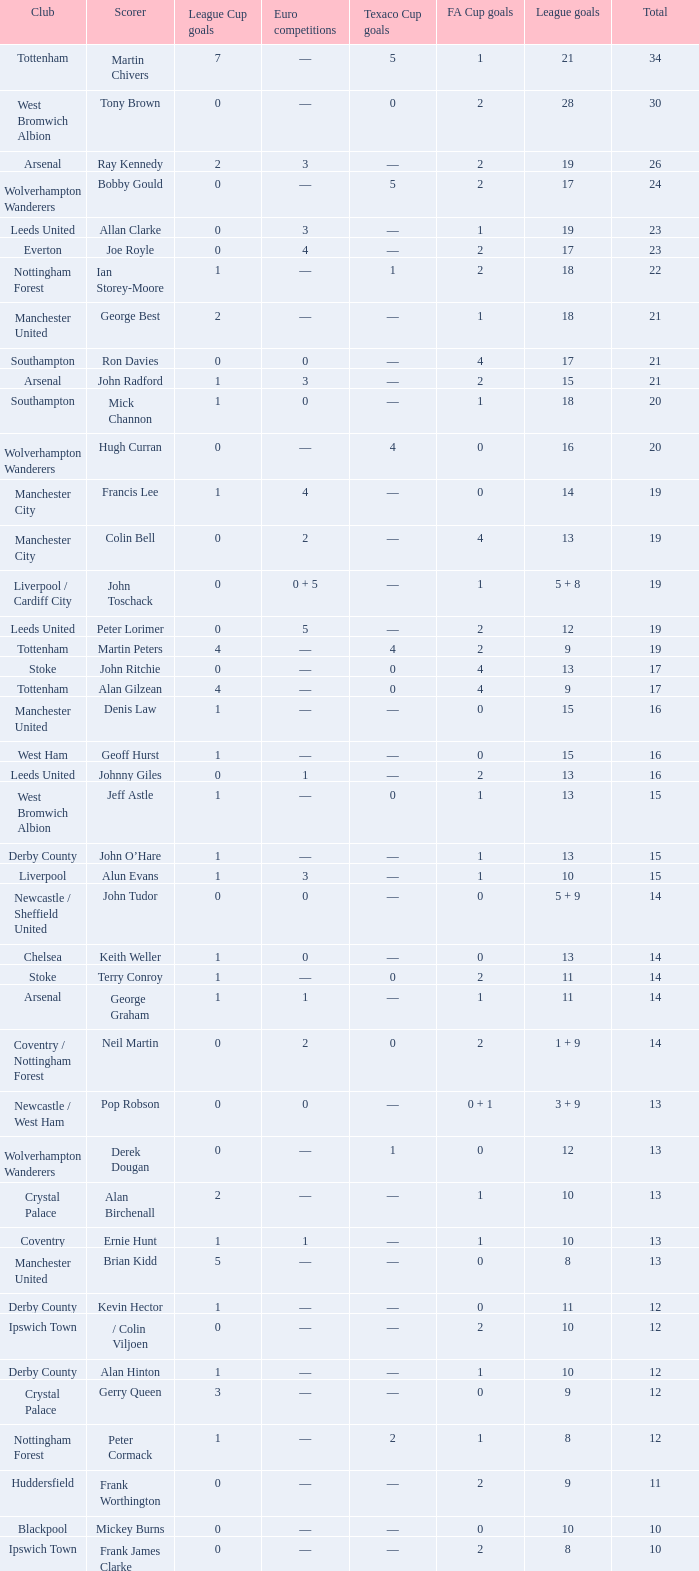What is the average Total, when FA Cup Goals is 1, when League Goals is 10, and when Club is Crystal Palace? 13.0. 